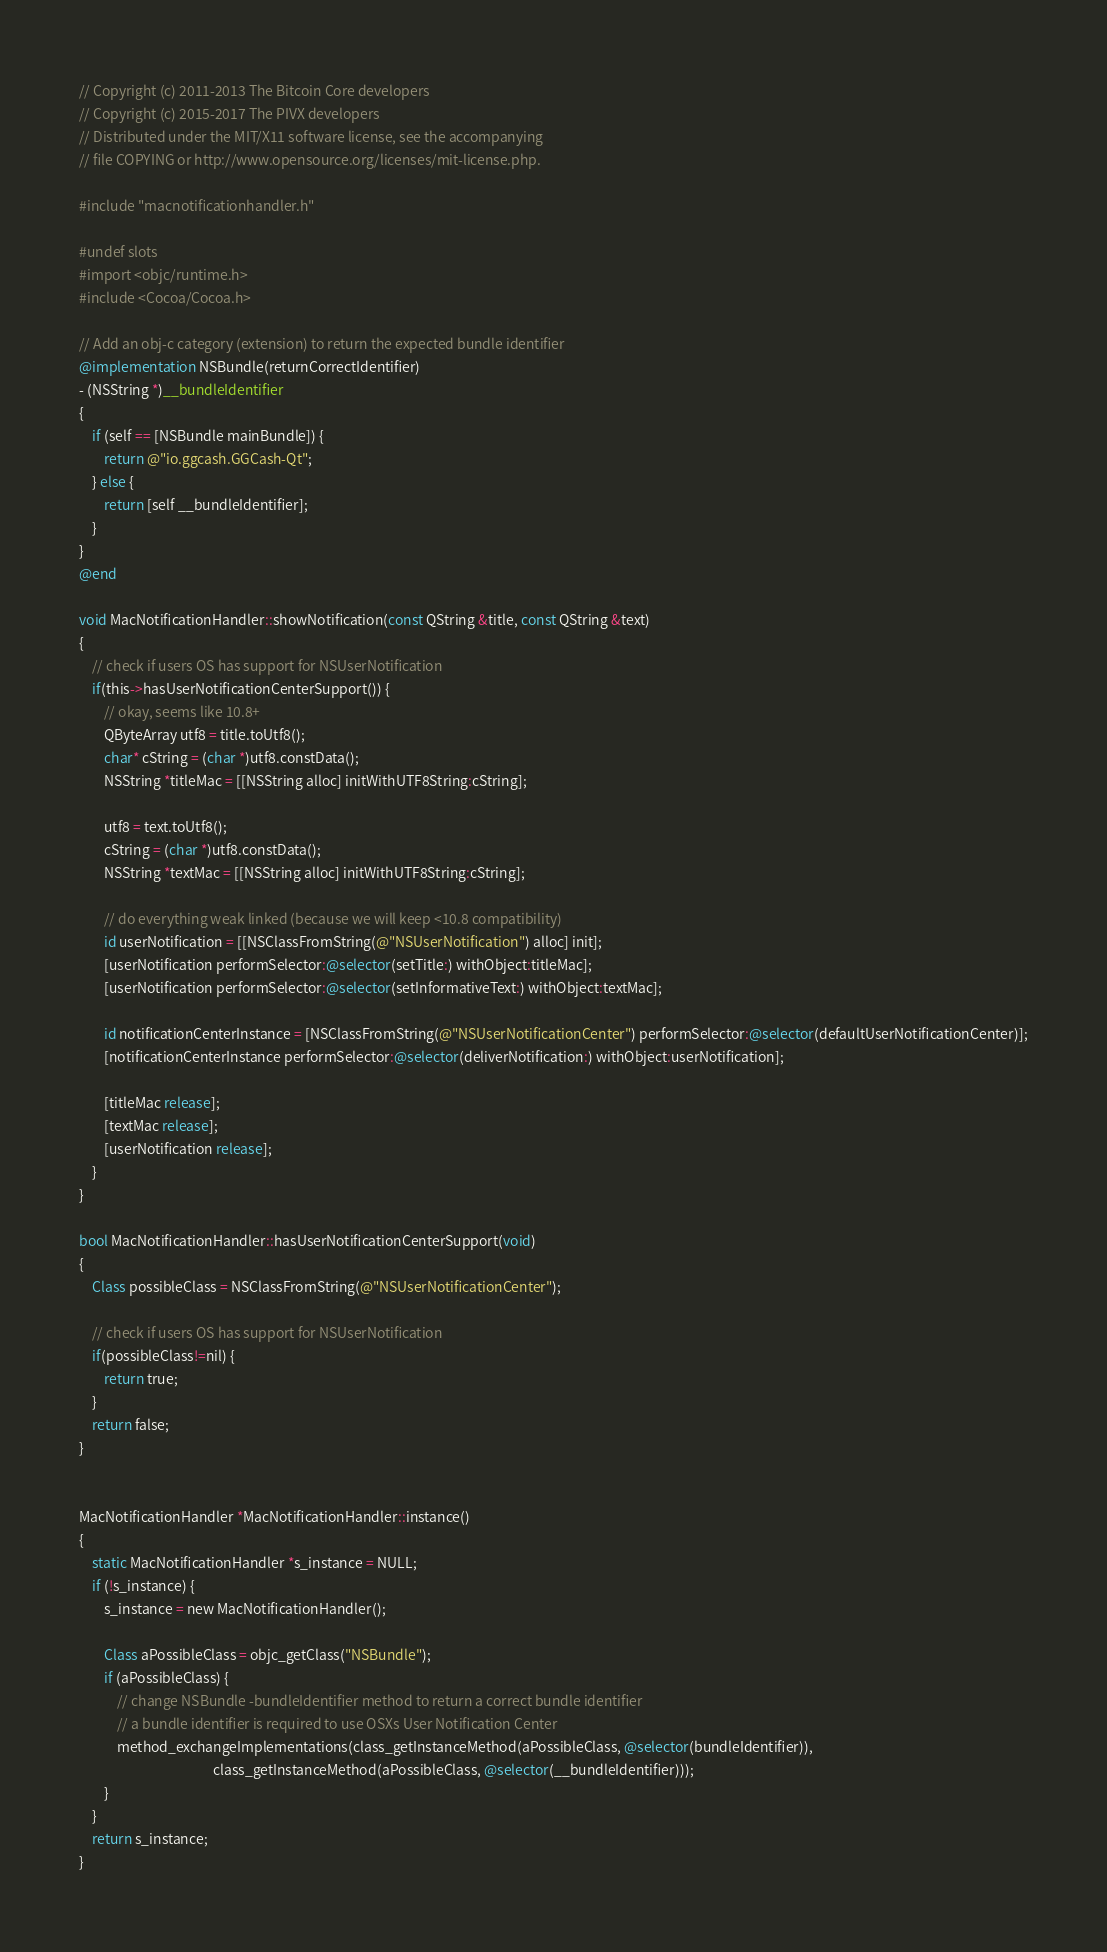Convert code to text. <code><loc_0><loc_0><loc_500><loc_500><_ObjectiveC_>// Copyright (c) 2011-2013 The Bitcoin Core developers
// Copyright (c) 2015-2017 The PIVX developers
// Distributed under the MIT/X11 software license, see the accompanying
// file COPYING or http://www.opensource.org/licenses/mit-license.php.

#include "macnotificationhandler.h"

#undef slots
#import <objc/runtime.h>
#include <Cocoa/Cocoa.h>

// Add an obj-c category (extension) to return the expected bundle identifier
@implementation NSBundle(returnCorrectIdentifier)
- (NSString *)__bundleIdentifier
{
    if (self == [NSBundle mainBundle]) {
        return @"io.ggcash.GGCash-Qt";
    } else {
        return [self __bundleIdentifier];
    }
}
@end

void MacNotificationHandler::showNotification(const QString &title, const QString &text)
{
    // check if users OS has support for NSUserNotification
    if(this->hasUserNotificationCenterSupport()) {
        // okay, seems like 10.8+
        QByteArray utf8 = title.toUtf8();
        char* cString = (char *)utf8.constData();
        NSString *titleMac = [[NSString alloc] initWithUTF8String:cString];

        utf8 = text.toUtf8();
        cString = (char *)utf8.constData();
        NSString *textMac = [[NSString alloc] initWithUTF8String:cString];

        // do everything weak linked (because we will keep <10.8 compatibility)
        id userNotification = [[NSClassFromString(@"NSUserNotification") alloc] init];
        [userNotification performSelector:@selector(setTitle:) withObject:titleMac];
        [userNotification performSelector:@selector(setInformativeText:) withObject:textMac];

        id notificationCenterInstance = [NSClassFromString(@"NSUserNotificationCenter") performSelector:@selector(defaultUserNotificationCenter)];
        [notificationCenterInstance performSelector:@selector(deliverNotification:) withObject:userNotification];

        [titleMac release];
        [textMac release];
        [userNotification release];
    }
}

bool MacNotificationHandler::hasUserNotificationCenterSupport(void)
{
    Class possibleClass = NSClassFromString(@"NSUserNotificationCenter");

    // check if users OS has support for NSUserNotification
    if(possibleClass!=nil) {
        return true;
    }
    return false;
}


MacNotificationHandler *MacNotificationHandler::instance()
{
    static MacNotificationHandler *s_instance = NULL;
    if (!s_instance) {
        s_instance = new MacNotificationHandler();
        
        Class aPossibleClass = objc_getClass("NSBundle");
        if (aPossibleClass) {
            // change NSBundle -bundleIdentifier method to return a correct bundle identifier
            // a bundle identifier is required to use OSXs User Notification Center
            method_exchangeImplementations(class_getInstanceMethod(aPossibleClass, @selector(bundleIdentifier)),
                                           class_getInstanceMethod(aPossibleClass, @selector(__bundleIdentifier)));
        }
    }
    return s_instance;
}
</code> 